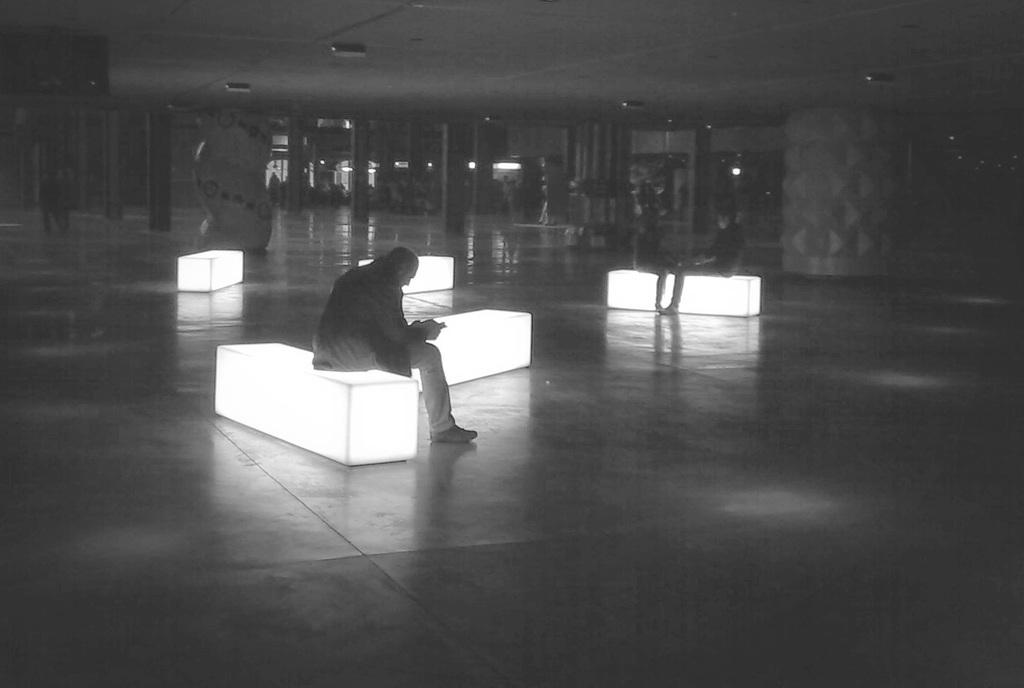What are the people in the image doing? The people in the image are sitting on seating stools. What type of lighting is present in the image? Electric lights are visible in the image. What structures can be seen in the image? Poles are present in the image. What type of haircut is the town known for in the image? There is no town present in the image, and therefore no haircut can be associated with it. 